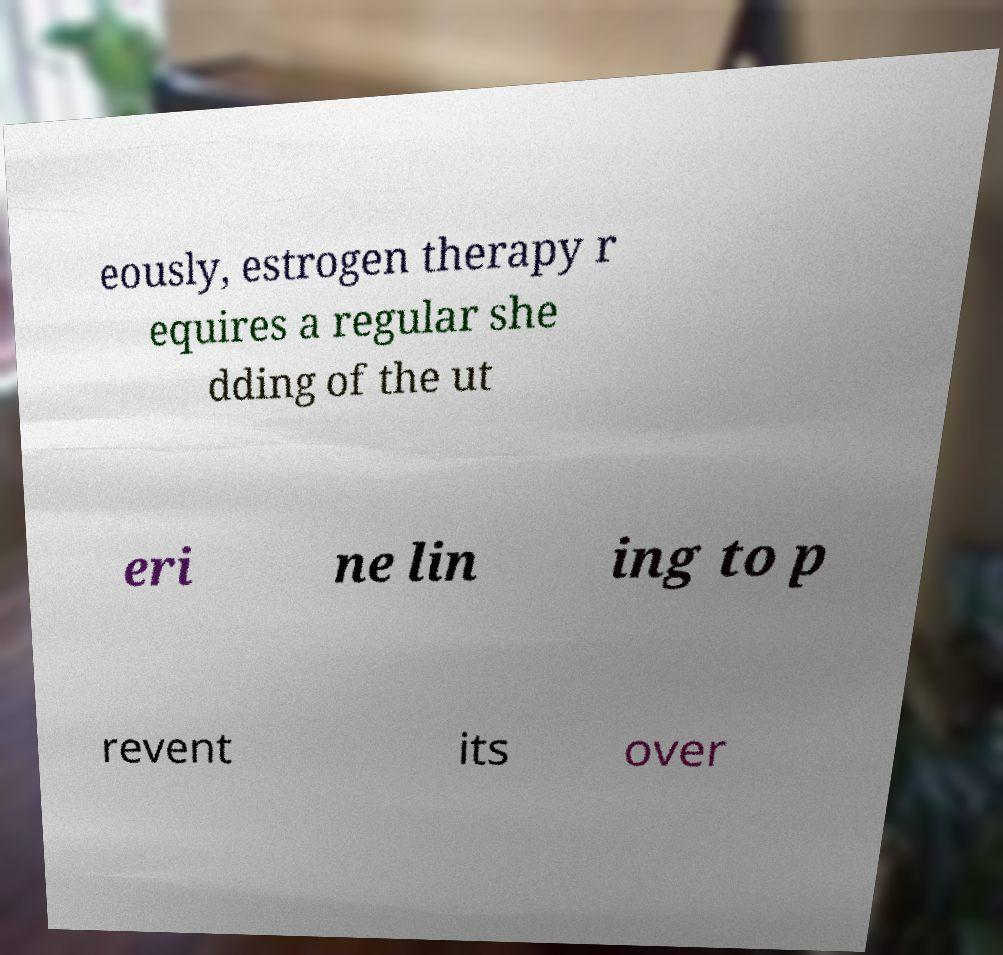Can you accurately transcribe the text from the provided image for me? eously, estrogen therapy r equires a regular she dding of the ut eri ne lin ing to p revent its over 